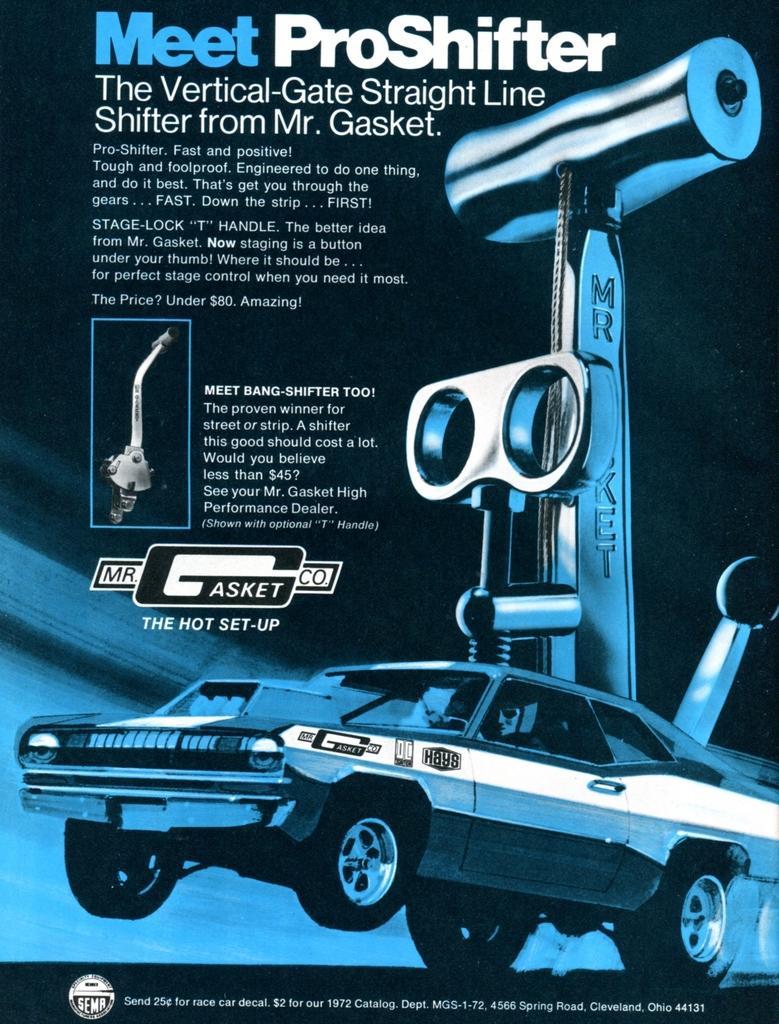Describe this image in one or two sentences. This image consists of a poster. On this poster, I can see some text and an image of car and a machine. 